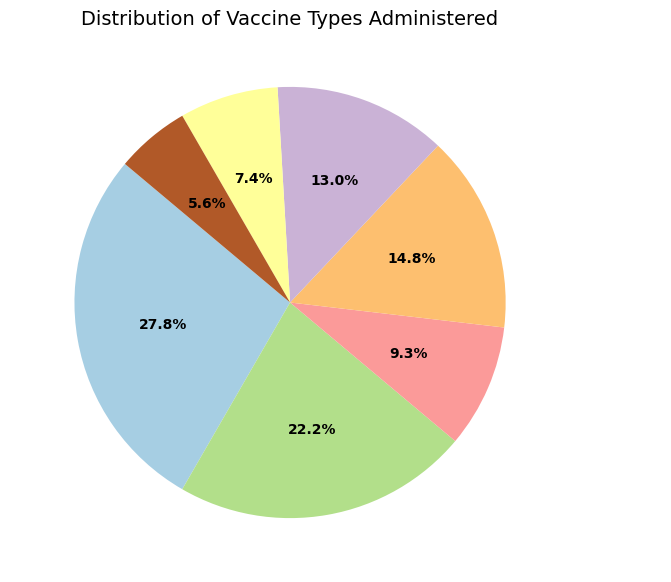What percentage of the administered vaccines are Pfizer and Moderna combined? To find this, sum the counts for Pfizer and Moderna, then divide by the total count of all vaccine types, and multiply by 100 to get the percentage. (1,500,000 + 1,200,000) / (1,500,000 + 1,200,000 + 500,000 + 800,000 + 700,000 + 400,000 + 300,000) * 100 = 48.6%
Answer: 48.6% Which vaccine type has the highest administration rate? By observing the pie chart, look for the largest wedge in the chart. Pfizer has the largest proportion at 32.1%.
Answer: Pfizer Are more AstraZeneca vaccines administered compared to Johnson & Johnson and Sputnik V combined? Sum the counts of Johnson & Johnson and Sputnik V and compare it to AstraZeneca's count. (500,000 + 400,000) = 900,000, which is greater than AstraZeneca's 800,000 count.
Answer: No What percentage of the graphical pie is represented by Sinopharm? From the pie chart, observe the percentage annotation next to Sinopharm. It shows 14.9%.
Answer: 14.9% Arrange the vaccine types in descending order of their administration rates. By inspecting the chart, list the wedges from the largest to smallest: Pfizer, Moderna, AstraZeneca, Sinopharm, Johnson & Johnson, Sputnik V, Covaxin.
Answer: Pfizer, Moderna, AstraZeneca, Sinopharm, Johnson & Johnson, Sputnik V, Covaxin How many more doses of Pfizer have been administered compared to Sinopharm? Subtract the count of Sinopharm from Pfizer's count. 1,500,000 - 700,000 = 800,000
Answer: 800,000 Which color represents the AstraZeneca vaccine on the pie chart? Inspect the pie chart and identify the corresponding wedge color for AstraZeneca. It is typically shown in one distinct color, which may vary depending on the default palette used.
Answer: [Inspect visual chart] Is the count of Covaxin vaccines greater than the combination of Sputnik V and Johnson & Johnson? Sum the counts of Sputnik V and Johnson & Johnson and compare it with Covaxin's count. 700,000 < (500,000 + 400,000) = 900,000.
Answer: No What is the difference between the counts of the most and least administered vaccines? Subtract the count of the least administered vaccine (Covaxin, 300,000) from the most administered vaccine (Pfizer, 1,500,000). 1,500,000 - 300,000 = 1,200,000
Answer: 1,200,000 